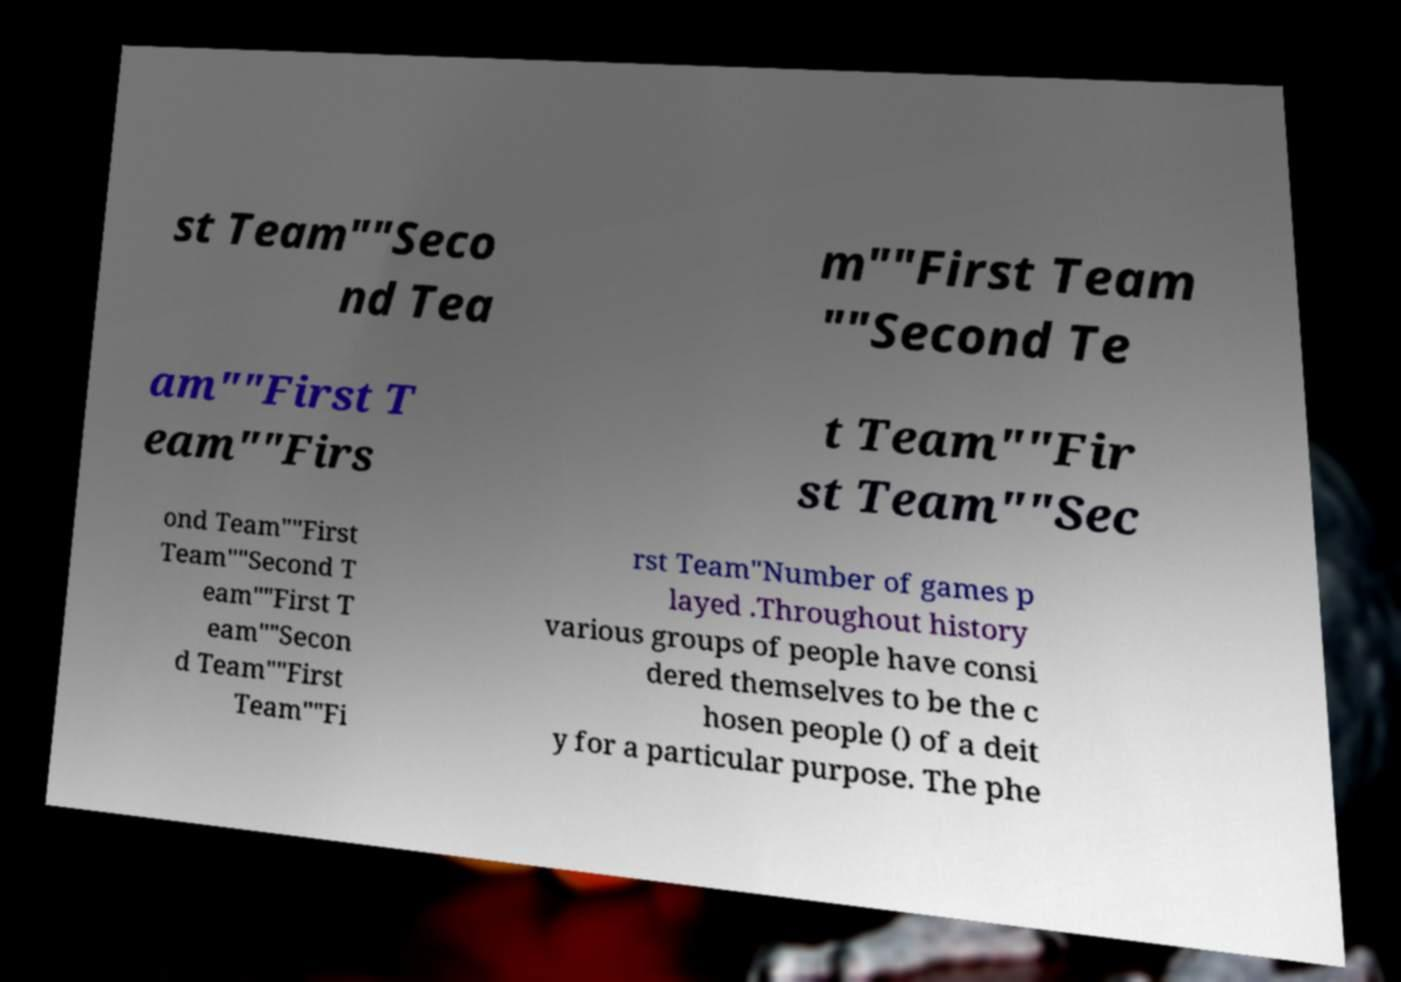Can you read and provide the text displayed in the image?This photo seems to have some interesting text. Can you extract and type it out for me? st Team""Seco nd Tea m""First Team ""Second Te am""First T eam""Firs t Team""Fir st Team""Sec ond Team""First Team""Second T eam""First T eam""Secon d Team""First Team""Fi rst Team"Number of games p layed .Throughout history various groups of people have consi dered themselves to be the c hosen people () of a deit y for a particular purpose. The phe 